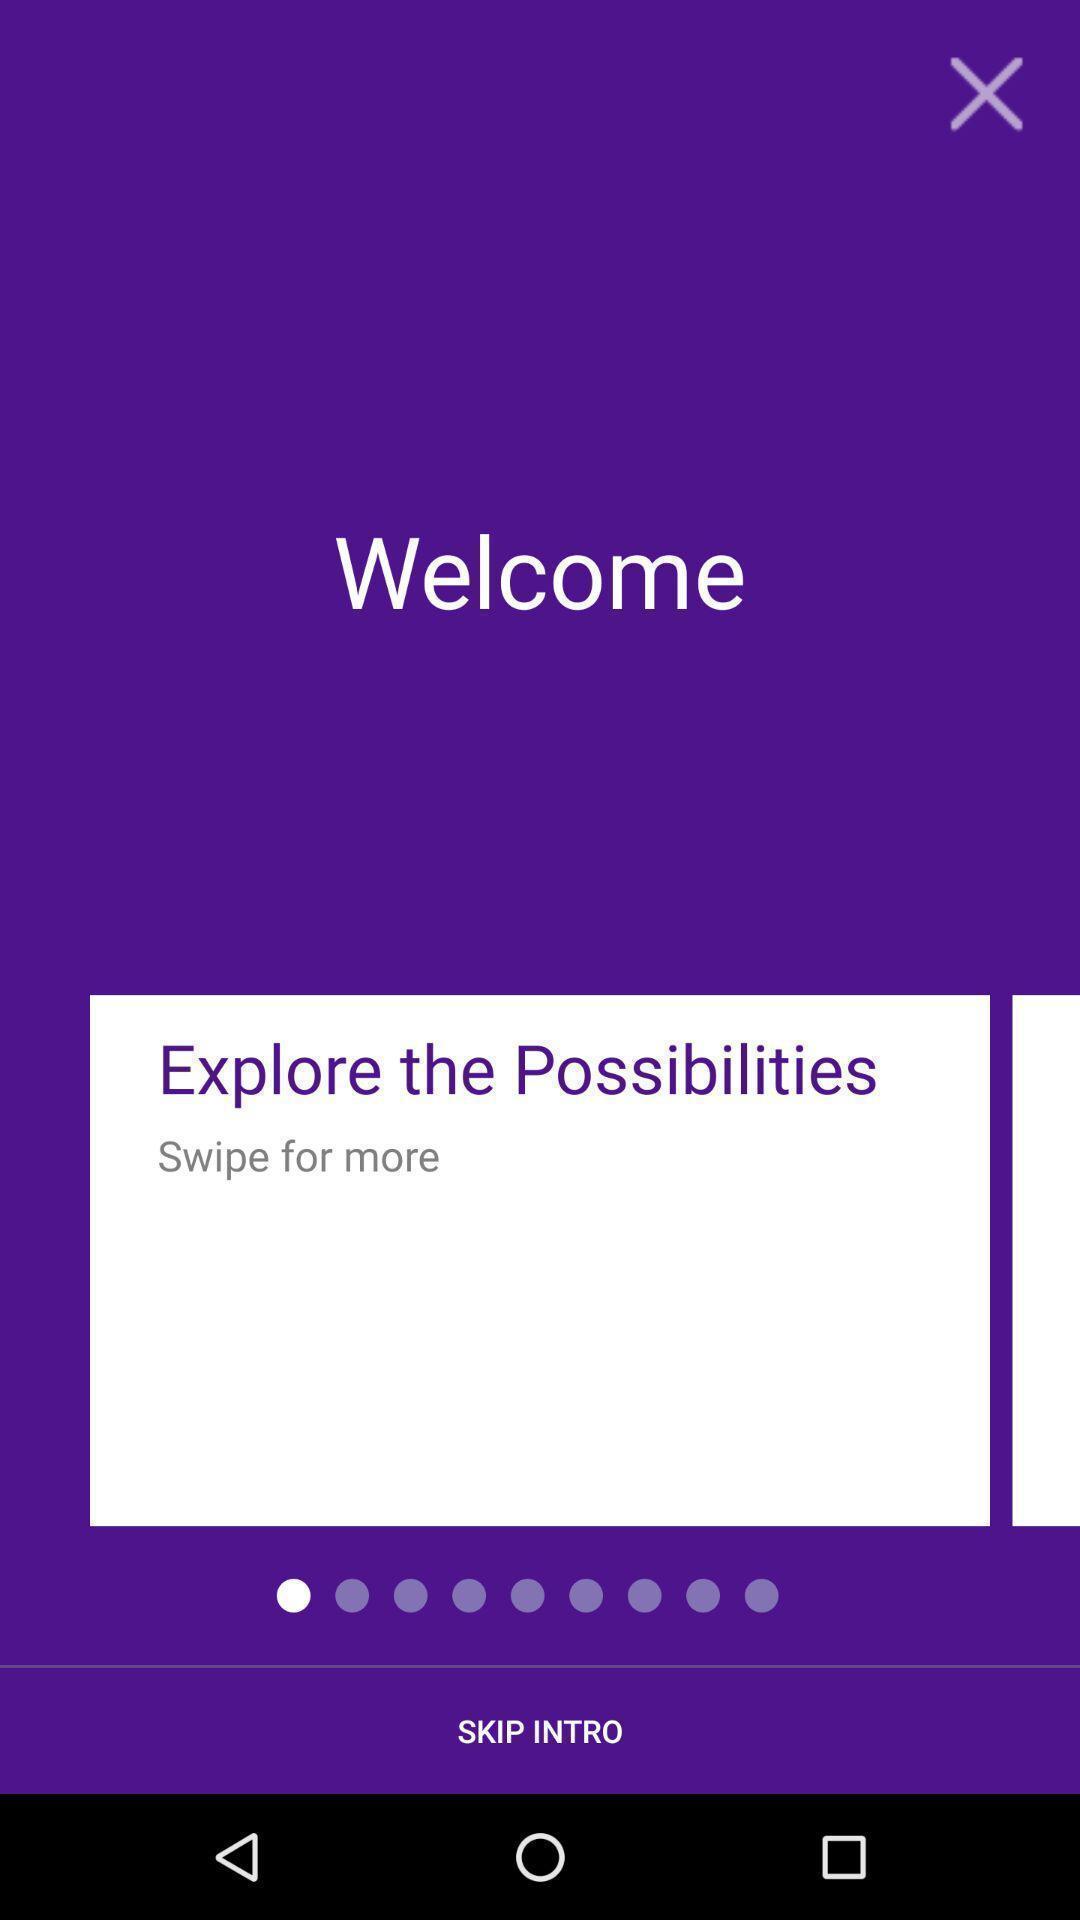Explain the elements present in this screenshot. Welcome page. 